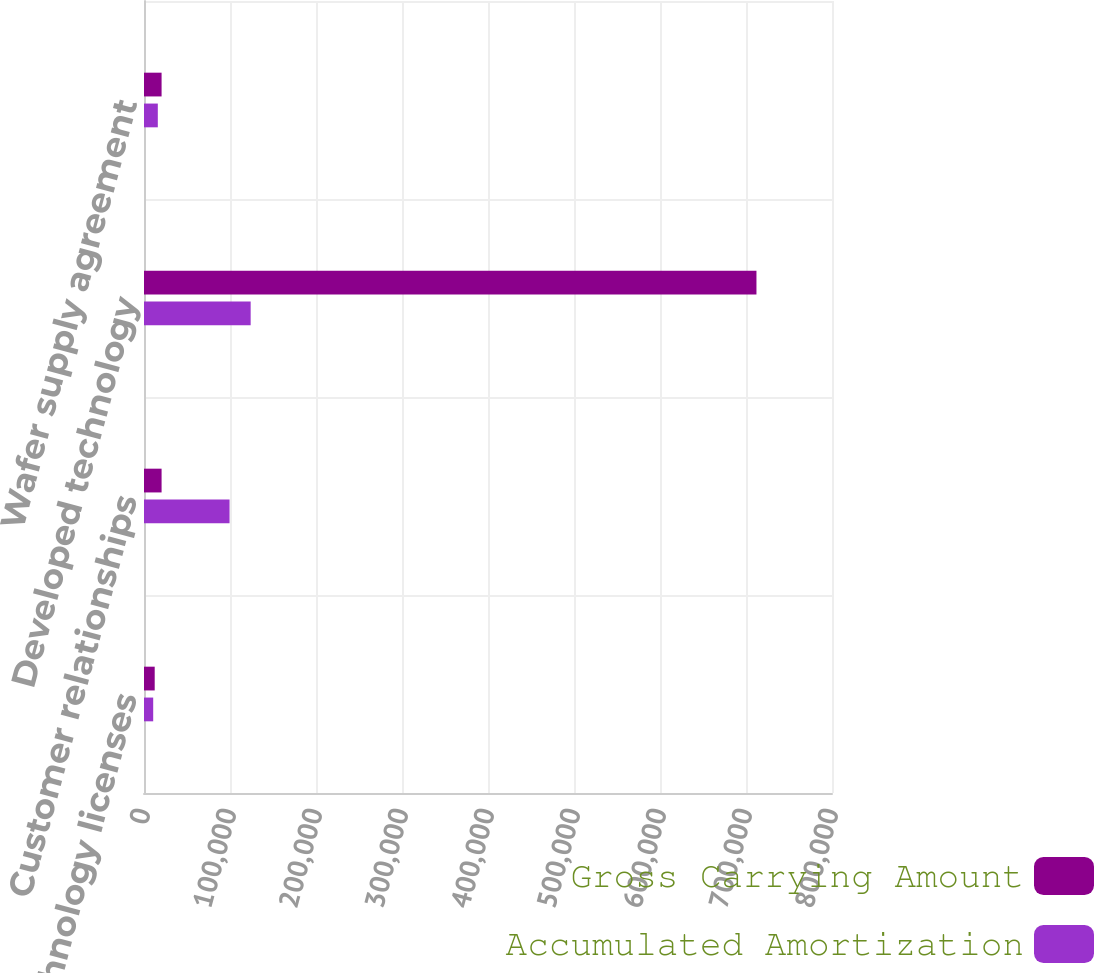Convert chart to OTSL. <chart><loc_0><loc_0><loc_500><loc_500><stacked_bar_chart><ecel><fcel>Technology licenses<fcel>Customer relationships<fcel>Developed technology<fcel>Wafer supply agreement<nl><fcel>Gross Carrying Amount<fcel>12446<fcel>20443<fcel>712163<fcel>20443<nl><fcel>Accumulated Amortization<fcel>10701<fcel>99471<fcel>124028<fcel>16059<nl></chart> 